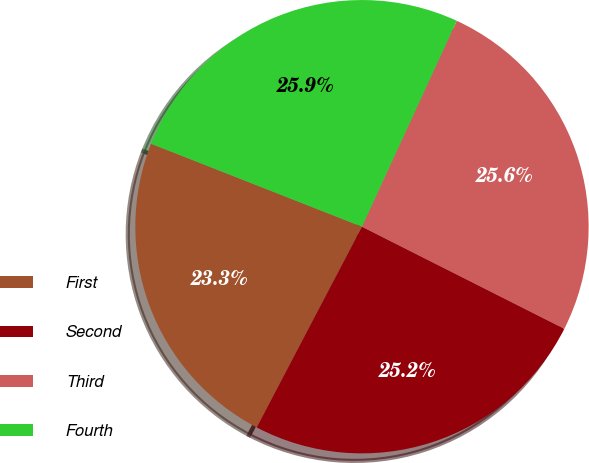<chart> <loc_0><loc_0><loc_500><loc_500><pie_chart><fcel>First<fcel>Second<fcel>Third<fcel>Fourth<nl><fcel>23.28%<fcel>25.25%<fcel>25.57%<fcel>25.9%<nl></chart> 